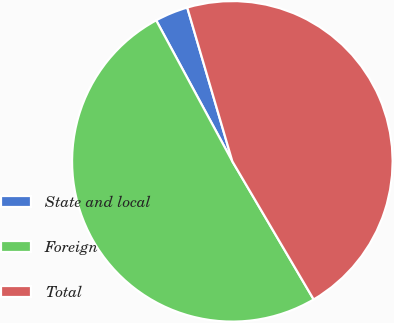<chart> <loc_0><loc_0><loc_500><loc_500><pie_chart><fcel>State and local<fcel>Foreign<fcel>Total<nl><fcel>3.34%<fcel>50.59%<fcel>46.07%<nl></chart> 